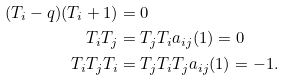Convert formula to latex. <formula><loc_0><loc_0><loc_500><loc_500>( T _ { i } - q ) ( T _ { i } + 1 ) & = 0 \\ T _ { i } T _ { j } & = T _ { j } T _ { i } a _ { i j } ( 1 ) = 0 \\ T _ { i } T _ { j } T _ { i } & = T _ { j } T _ { i } T _ { j } a _ { i j } ( 1 ) = - 1 .</formula> 